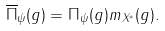Convert formula to latex. <formula><loc_0><loc_0><loc_500><loc_500>\overline { \Pi } _ { \psi } ( g ) = \Pi _ { \psi } ( g ) m _ { X ^ { \ast } } ( g ) .</formula> 